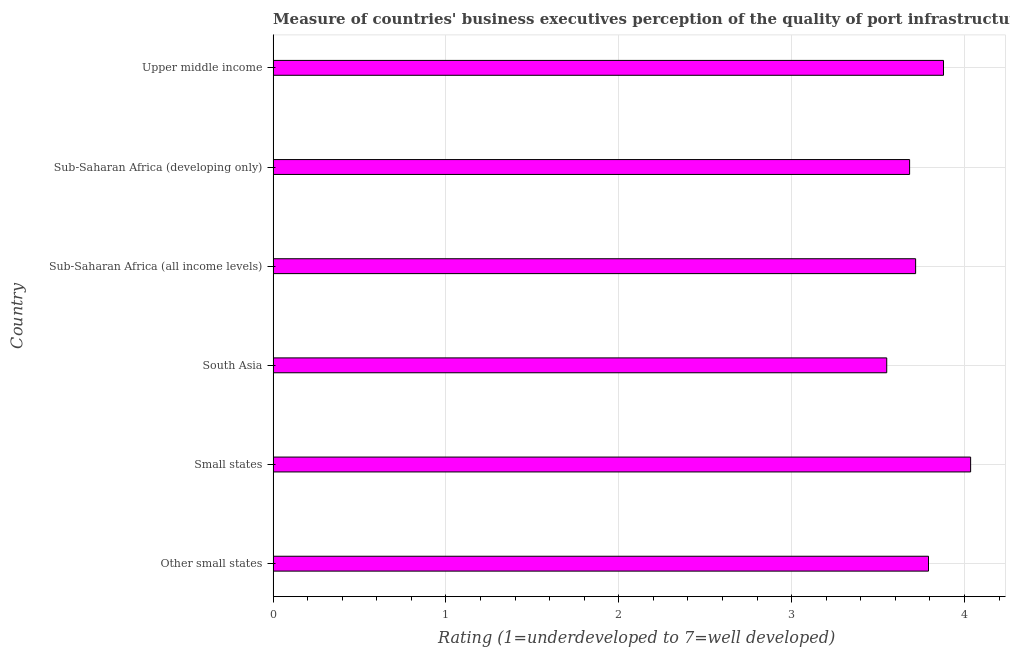Does the graph contain any zero values?
Ensure brevity in your answer.  No. Does the graph contain grids?
Give a very brief answer. Yes. What is the title of the graph?
Ensure brevity in your answer.  Measure of countries' business executives perception of the quality of port infrastructure in 2013. What is the label or title of the X-axis?
Offer a terse response. Rating (1=underdeveloped to 7=well developed) . What is the label or title of the Y-axis?
Give a very brief answer. Country. What is the rating measuring quality of port infrastructure in Sub-Saharan Africa (all income levels)?
Your answer should be very brief. 3.72. Across all countries, what is the maximum rating measuring quality of port infrastructure?
Your answer should be very brief. 4.04. Across all countries, what is the minimum rating measuring quality of port infrastructure?
Give a very brief answer. 3.55. In which country was the rating measuring quality of port infrastructure maximum?
Offer a very short reply. Small states. In which country was the rating measuring quality of port infrastructure minimum?
Your answer should be compact. South Asia. What is the sum of the rating measuring quality of port infrastructure?
Give a very brief answer. 22.65. What is the difference between the rating measuring quality of port infrastructure in Small states and Sub-Saharan Africa (all income levels)?
Offer a very short reply. 0.32. What is the average rating measuring quality of port infrastructure per country?
Offer a terse response. 3.78. What is the median rating measuring quality of port infrastructure?
Give a very brief answer. 3.75. What is the difference between the highest and the second highest rating measuring quality of port infrastructure?
Provide a succinct answer. 0.16. What is the difference between the highest and the lowest rating measuring quality of port infrastructure?
Give a very brief answer. 0.49. How many bars are there?
Ensure brevity in your answer.  6. Are all the bars in the graph horizontal?
Make the answer very short. Yes. How many countries are there in the graph?
Keep it short and to the point. 6. What is the difference between two consecutive major ticks on the X-axis?
Provide a succinct answer. 1. What is the Rating (1=underdeveloped to 7=well developed)  in Other small states?
Your answer should be very brief. 3.79. What is the Rating (1=underdeveloped to 7=well developed)  in Small states?
Your answer should be compact. 4.04. What is the Rating (1=underdeveloped to 7=well developed)  in South Asia?
Keep it short and to the point. 3.55. What is the Rating (1=underdeveloped to 7=well developed)  in Sub-Saharan Africa (all income levels)?
Provide a short and direct response. 3.72. What is the Rating (1=underdeveloped to 7=well developed)  in Sub-Saharan Africa (developing only)?
Offer a terse response. 3.68. What is the Rating (1=underdeveloped to 7=well developed)  of Upper middle income?
Keep it short and to the point. 3.88. What is the difference between the Rating (1=underdeveloped to 7=well developed)  in Other small states and Small states?
Give a very brief answer. -0.24. What is the difference between the Rating (1=underdeveloped to 7=well developed)  in Other small states and South Asia?
Keep it short and to the point. 0.24. What is the difference between the Rating (1=underdeveloped to 7=well developed)  in Other small states and Sub-Saharan Africa (all income levels)?
Give a very brief answer. 0.07. What is the difference between the Rating (1=underdeveloped to 7=well developed)  in Other small states and Sub-Saharan Africa (developing only)?
Give a very brief answer. 0.11. What is the difference between the Rating (1=underdeveloped to 7=well developed)  in Other small states and Upper middle income?
Ensure brevity in your answer.  -0.09. What is the difference between the Rating (1=underdeveloped to 7=well developed)  in Small states and South Asia?
Provide a short and direct response. 0.49. What is the difference between the Rating (1=underdeveloped to 7=well developed)  in Small states and Sub-Saharan Africa (all income levels)?
Ensure brevity in your answer.  0.32. What is the difference between the Rating (1=underdeveloped to 7=well developed)  in Small states and Sub-Saharan Africa (developing only)?
Keep it short and to the point. 0.35. What is the difference between the Rating (1=underdeveloped to 7=well developed)  in Small states and Upper middle income?
Provide a short and direct response. 0.16. What is the difference between the Rating (1=underdeveloped to 7=well developed)  in South Asia and Sub-Saharan Africa (all income levels)?
Offer a very short reply. -0.17. What is the difference between the Rating (1=underdeveloped to 7=well developed)  in South Asia and Sub-Saharan Africa (developing only)?
Your response must be concise. -0.13. What is the difference between the Rating (1=underdeveloped to 7=well developed)  in South Asia and Upper middle income?
Your answer should be compact. -0.33. What is the difference between the Rating (1=underdeveloped to 7=well developed)  in Sub-Saharan Africa (all income levels) and Sub-Saharan Africa (developing only)?
Give a very brief answer. 0.03. What is the difference between the Rating (1=underdeveloped to 7=well developed)  in Sub-Saharan Africa (all income levels) and Upper middle income?
Provide a succinct answer. -0.16. What is the difference between the Rating (1=underdeveloped to 7=well developed)  in Sub-Saharan Africa (developing only) and Upper middle income?
Make the answer very short. -0.2. What is the ratio of the Rating (1=underdeveloped to 7=well developed)  in Other small states to that in South Asia?
Offer a very short reply. 1.07. What is the ratio of the Rating (1=underdeveloped to 7=well developed)  in Other small states to that in Sub-Saharan Africa (developing only)?
Keep it short and to the point. 1.03. What is the ratio of the Rating (1=underdeveloped to 7=well developed)  in Small states to that in South Asia?
Provide a succinct answer. 1.14. What is the ratio of the Rating (1=underdeveloped to 7=well developed)  in Small states to that in Sub-Saharan Africa (all income levels)?
Make the answer very short. 1.09. What is the ratio of the Rating (1=underdeveloped to 7=well developed)  in Small states to that in Sub-Saharan Africa (developing only)?
Keep it short and to the point. 1.1. What is the ratio of the Rating (1=underdeveloped to 7=well developed)  in Small states to that in Upper middle income?
Ensure brevity in your answer.  1.04. What is the ratio of the Rating (1=underdeveloped to 7=well developed)  in South Asia to that in Sub-Saharan Africa (all income levels)?
Provide a short and direct response. 0.95. What is the ratio of the Rating (1=underdeveloped to 7=well developed)  in South Asia to that in Upper middle income?
Make the answer very short. 0.92. What is the ratio of the Rating (1=underdeveloped to 7=well developed)  in Sub-Saharan Africa (all income levels) to that in Sub-Saharan Africa (developing only)?
Your answer should be very brief. 1.01. What is the ratio of the Rating (1=underdeveloped to 7=well developed)  in Sub-Saharan Africa (all income levels) to that in Upper middle income?
Offer a terse response. 0.96. What is the ratio of the Rating (1=underdeveloped to 7=well developed)  in Sub-Saharan Africa (developing only) to that in Upper middle income?
Make the answer very short. 0.95. 